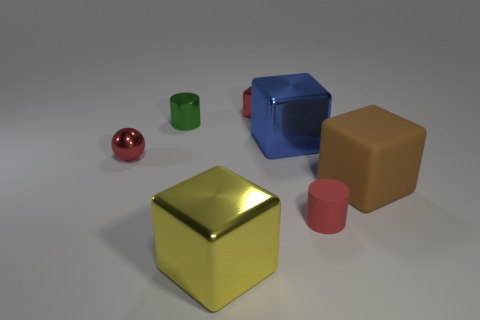Add 2 large brown blocks. How many objects exist? 9 Subtract all spheres. How many objects are left? 6 Subtract 1 green cylinders. How many objects are left? 6 Subtract all large blue shiny cylinders. Subtract all tiny green cylinders. How many objects are left? 6 Add 3 red balls. How many red balls are left? 4 Add 4 green metallic things. How many green metallic things exist? 5 